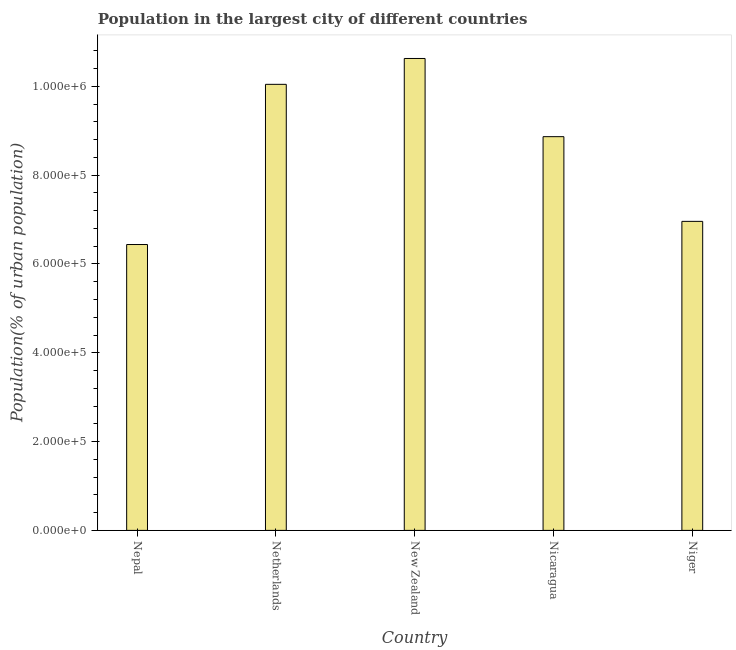What is the title of the graph?
Make the answer very short. Population in the largest city of different countries. What is the label or title of the Y-axis?
Give a very brief answer. Population(% of urban population). What is the population in largest city in Nepal?
Your answer should be compact. 6.44e+05. Across all countries, what is the maximum population in largest city?
Provide a succinct answer. 1.06e+06. Across all countries, what is the minimum population in largest city?
Provide a succinct answer. 6.44e+05. In which country was the population in largest city maximum?
Make the answer very short. New Zealand. In which country was the population in largest city minimum?
Give a very brief answer. Nepal. What is the sum of the population in largest city?
Provide a succinct answer. 4.29e+06. What is the difference between the population in largest city in Netherlands and New Zealand?
Keep it short and to the point. -5.83e+04. What is the average population in largest city per country?
Your answer should be compact. 8.59e+05. What is the median population in largest city?
Your response must be concise. 8.87e+05. In how many countries, is the population in largest city greater than 40000 %?
Your response must be concise. 5. What is the ratio of the population in largest city in Nicaragua to that in Niger?
Give a very brief answer. 1.27. What is the difference between the highest and the second highest population in largest city?
Make the answer very short. 5.83e+04. What is the difference between the highest and the lowest population in largest city?
Your response must be concise. 4.19e+05. In how many countries, is the population in largest city greater than the average population in largest city taken over all countries?
Your answer should be very brief. 3. How many bars are there?
Give a very brief answer. 5. Are all the bars in the graph horizontal?
Your response must be concise. No. What is the Population(% of urban population) in Nepal?
Keep it short and to the point. 6.44e+05. What is the Population(% of urban population) of Netherlands?
Your answer should be compact. 1.00e+06. What is the Population(% of urban population) of New Zealand?
Make the answer very short. 1.06e+06. What is the Population(% of urban population) in Nicaragua?
Offer a very short reply. 8.87e+05. What is the Population(% of urban population) of Niger?
Offer a terse response. 6.96e+05. What is the difference between the Population(% of urban population) in Nepal and Netherlands?
Keep it short and to the point. -3.61e+05. What is the difference between the Population(% of urban population) in Nepal and New Zealand?
Give a very brief answer. -4.19e+05. What is the difference between the Population(% of urban population) in Nepal and Nicaragua?
Provide a short and direct response. -2.43e+05. What is the difference between the Population(% of urban population) in Nepal and Niger?
Provide a short and direct response. -5.21e+04. What is the difference between the Population(% of urban population) in Netherlands and New Zealand?
Keep it short and to the point. -5.83e+04. What is the difference between the Population(% of urban population) in Netherlands and Nicaragua?
Offer a terse response. 1.18e+05. What is the difference between the Population(% of urban population) in Netherlands and Niger?
Ensure brevity in your answer.  3.09e+05. What is the difference between the Population(% of urban population) in New Zealand and Nicaragua?
Keep it short and to the point. 1.76e+05. What is the difference between the Population(% of urban population) in New Zealand and Niger?
Provide a short and direct response. 3.67e+05. What is the difference between the Population(% of urban population) in Nicaragua and Niger?
Ensure brevity in your answer.  1.91e+05. What is the ratio of the Population(% of urban population) in Nepal to that in Netherlands?
Provide a short and direct response. 0.64. What is the ratio of the Population(% of urban population) in Nepal to that in New Zealand?
Keep it short and to the point. 0.61. What is the ratio of the Population(% of urban population) in Nepal to that in Nicaragua?
Offer a very short reply. 0.73. What is the ratio of the Population(% of urban population) in Nepal to that in Niger?
Offer a very short reply. 0.93. What is the ratio of the Population(% of urban population) in Netherlands to that in New Zealand?
Ensure brevity in your answer.  0.94. What is the ratio of the Population(% of urban population) in Netherlands to that in Nicaragua?
Your response must be concise. 1.13. What is the ratio of the Population(% of urban population) in Netherlands to that in Niger?
Keep it short and to the point. 1.44. What is the ratio of the Population(% of urban population) in New Zealand to that in Nicaragua?
Offer a very short reply. 1.2. What is the ratio of the Population(% of urban population) in New Zealand to that in Niger?
Your answer should be very brief. 1.53. What is the ratio of the Population(% of urban population) in Nicaragua to that in Niger?
Offer a very short reply. 1.27. 